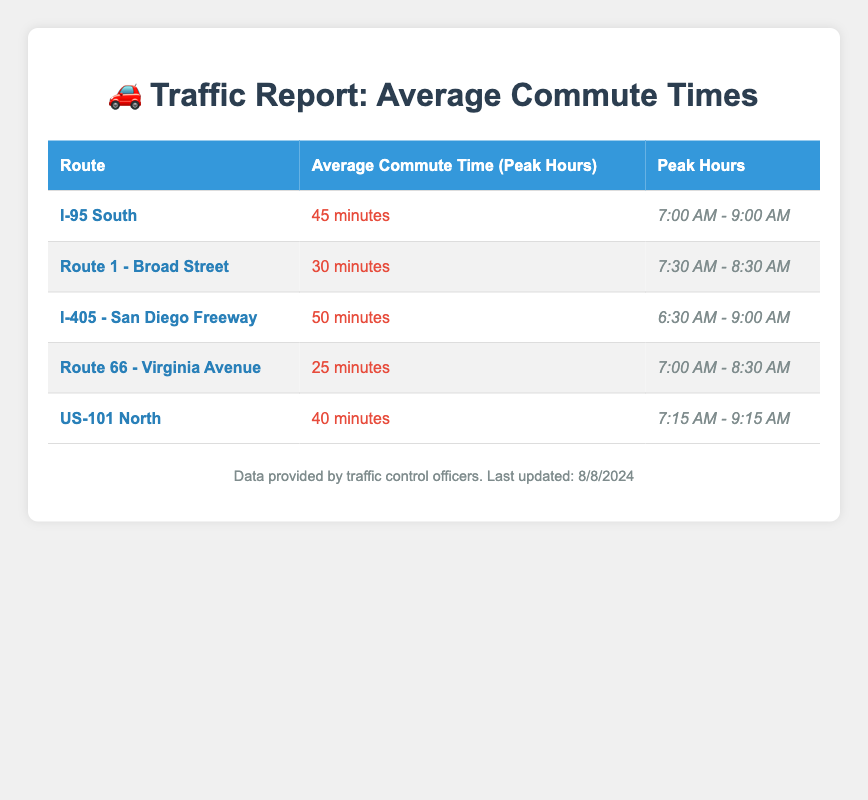What is the average commute time for the I-405 - San Diego Freeway? The average commute time for the I-405 - San Diego Freeway is listed directly in the table under the relevant row. It states 50 minutes.
Answer: 50 minutes Which route has the shortest average commute time during peak hours? By reviewing the average commute times for each route in the table, Route 66 - Virginia Avenue has the shortest time of 25 minutes, as highlighted in its row.
Answer: Route 66 - Virginia Avenue What is the peak time for Route 1 - Broad Street? The peak hours for Route 1 - Broad Street are given in the table, specifically listed as 7:30 AM - 8:30 AM.
Answer: 7:30 AM - 8:30 AM If a commuter takes I-95 South and US-101 North, what is the total average commute time during their peak hours? The average commute time for I-95 South is 45 minutes and for US-101 North is 40 minutes. Adding these together (45 + 40) gives a total of 85 minutes.
Answer: 85 minutes Is the average commute time for I-405 - San Diego Freeway longer than that for I-95 South? The average commute time for I-405 - San Diego Freeway is 50 minutes, while for I-95 South it is 45 minutes. Since 50 is greater than 45, the statement is true.
Answer: Yes During which times does US-101 North have peak hours? The peak hours for US-101 North are provided in the table, which states 7:15 AM - 9:15 AM. Therefore, this is the answer.
Answer: 7:15 AM - 9:15 AM What is the average commute time difference between Route 66 - Virginia Avenue and I-405 - San Diego Freeway? Route 66 - Virginia Avenue has an average commute time of 25 minutes, while I-405 - San Diego Freeway has 50 minutes. The difference is calculated by subtracting these times: 50 - 25 = 25 minutes.
Answer: 25 minutes Are the peak hours for I-95 South overlapping with those of Route 1 - Broad Street? The peak hours for I-95 South are from 7:00 AM - 9:00 AM and for Route 1 - Broad Street from 7:30 AM - 8:30 AM. Since Route 1 starts at 7:30 AM and ends at 8:30 AM, which falls within the I-95 peak hours, they do overlap.
Answer: Yes 